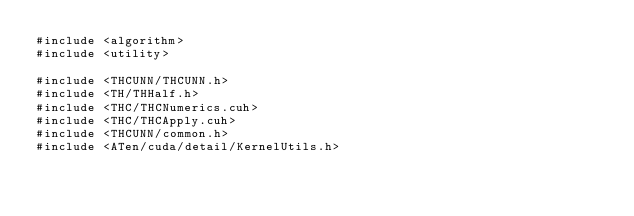Convert code to text. <code><loc_0><loc_0><loc_500><loc_500><_Cuda_>#include <algorithm>
#include <utility>

#include <THCUNN/THCUNN.h>
#include <TH/THHalf.h>
#include <THC/THCNumerics.cuh>
#include <THC/THCApply.cuh>
#include <THCUNN/common.h>
#include <ATen/cuda/detail/KernelUtils.h></code> 